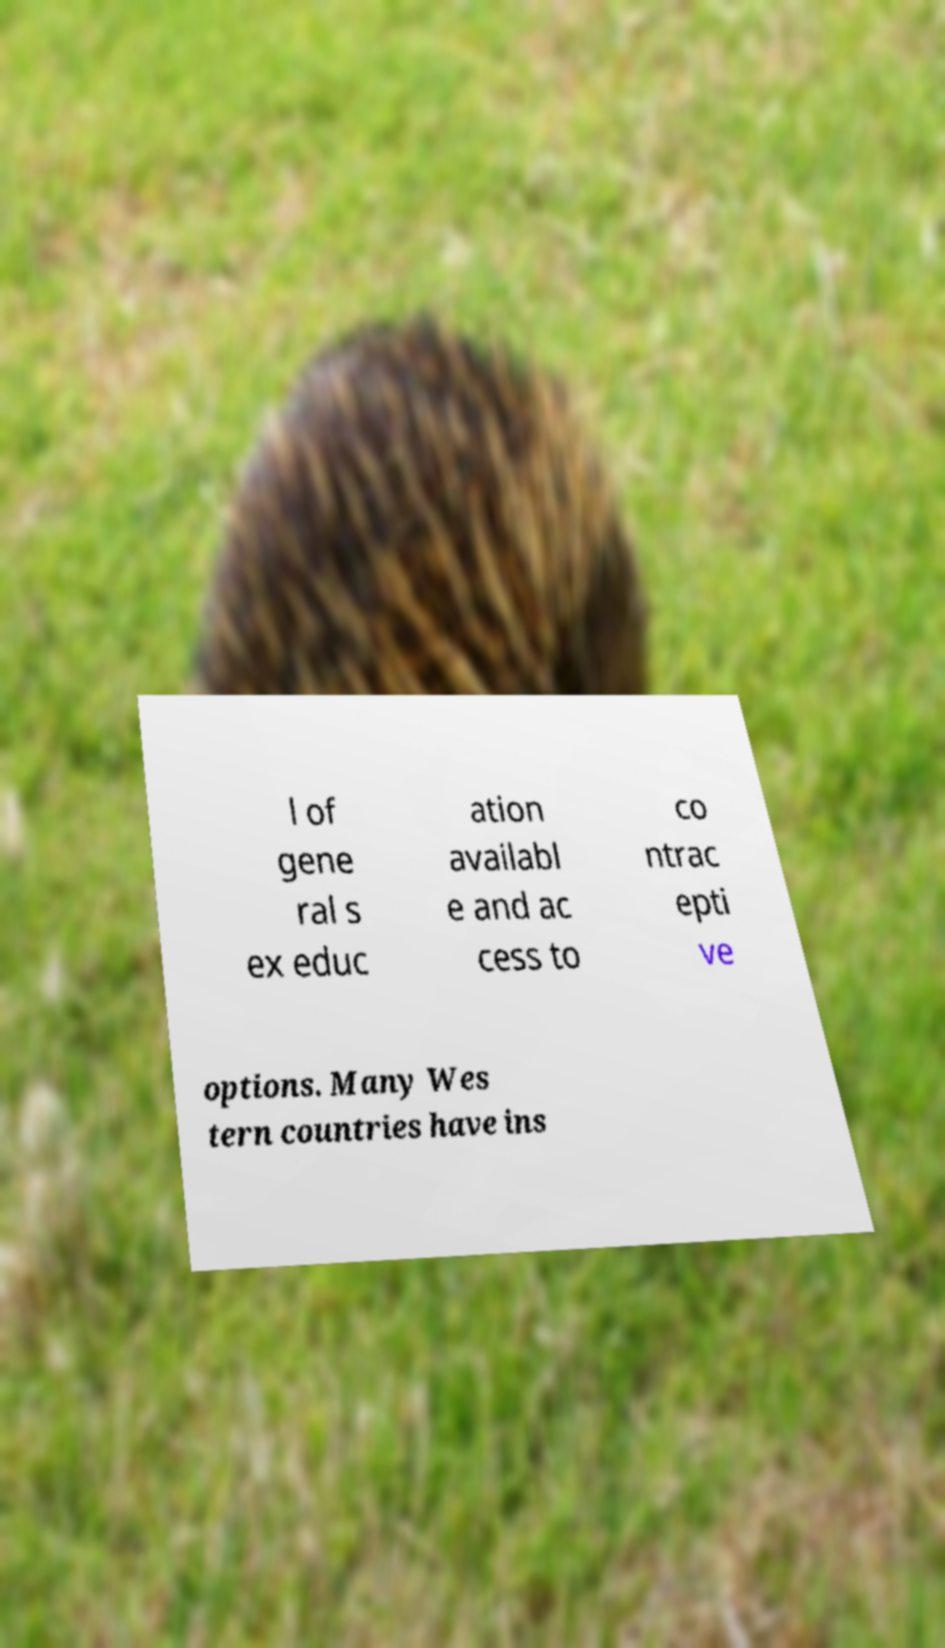Please identify and transcribe the text found in this image. l of gene ral s ex educ ation availabl e and ac cess to co ntrac epti ve options. Many Wes tern countries have ins 